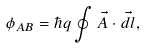<formula> <loc_0><loc_0><loc_500><loc_500>\phi _ { A B } = \hbar { q } \oint \vec { A } \cdot \vec { d } l ,</formula> 